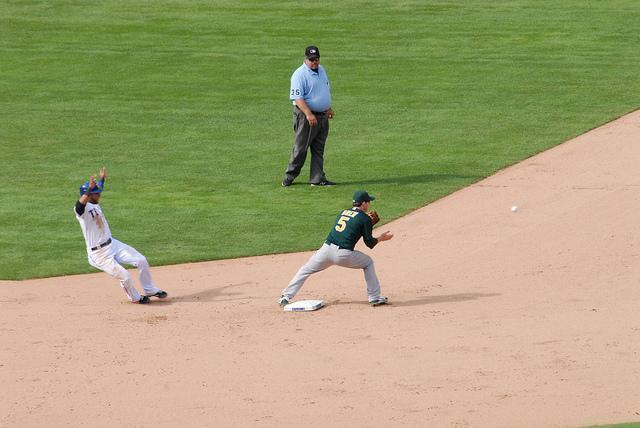How many people are in the picture?
Give a very brief answer. 3. 